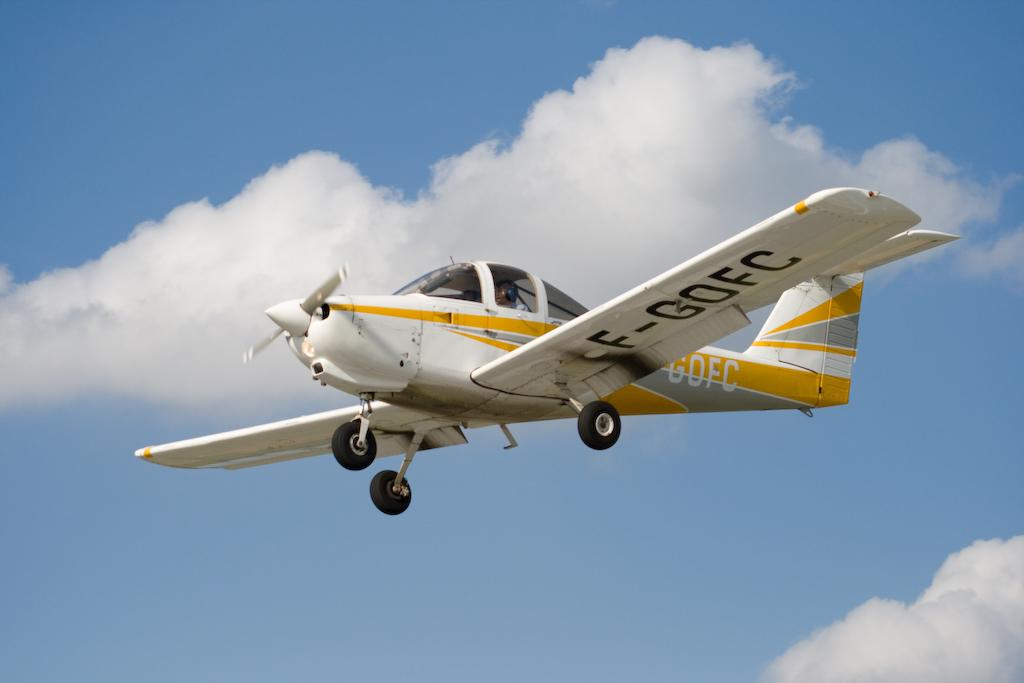<image>
Write a terse but informative summary of the picture. A grey, white and yellow small plane with F-GOFC written under the left wing. 